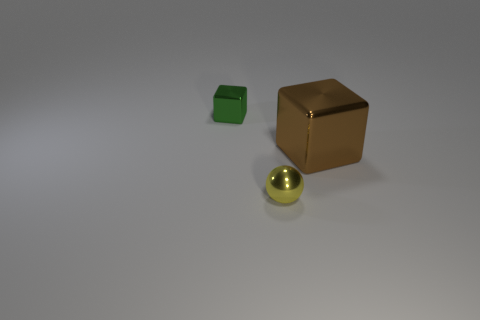How many cubes are green metal objects or brown shiny objects? 2 